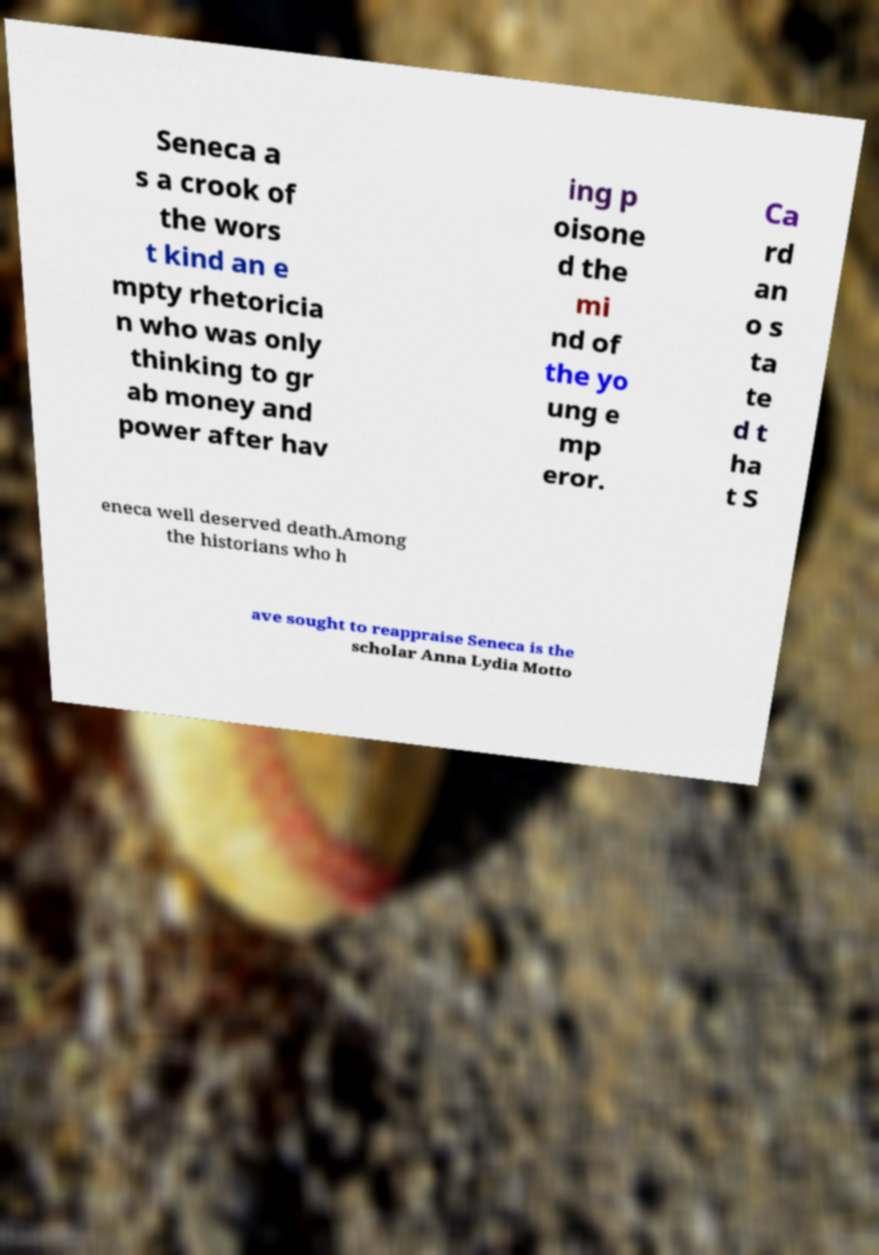Could you assist in decoding the text presented in this image and type it out clearly? Seneca a s a crook of the wors t kind an e mpty rhetoricia n who was only thinking to gr ab money and power after hav ing p oisone d the mi nd of the yo ung e mp eror. Ca rd an o s ta te d t ha t S eneca well deserved death.Among the historians who h ave sought to reappraise Seneca is the scholar Anna Lydia Motto 